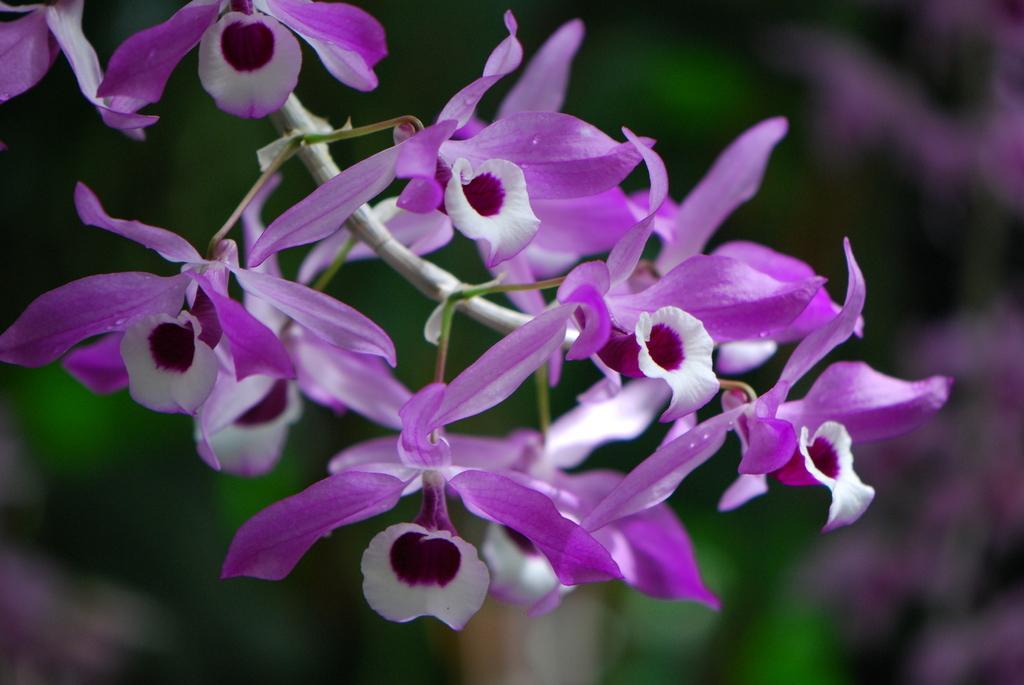In one or two sentences, can you explain what this image depicts? In this image we can see some flowers and in the background the image is blurred. 